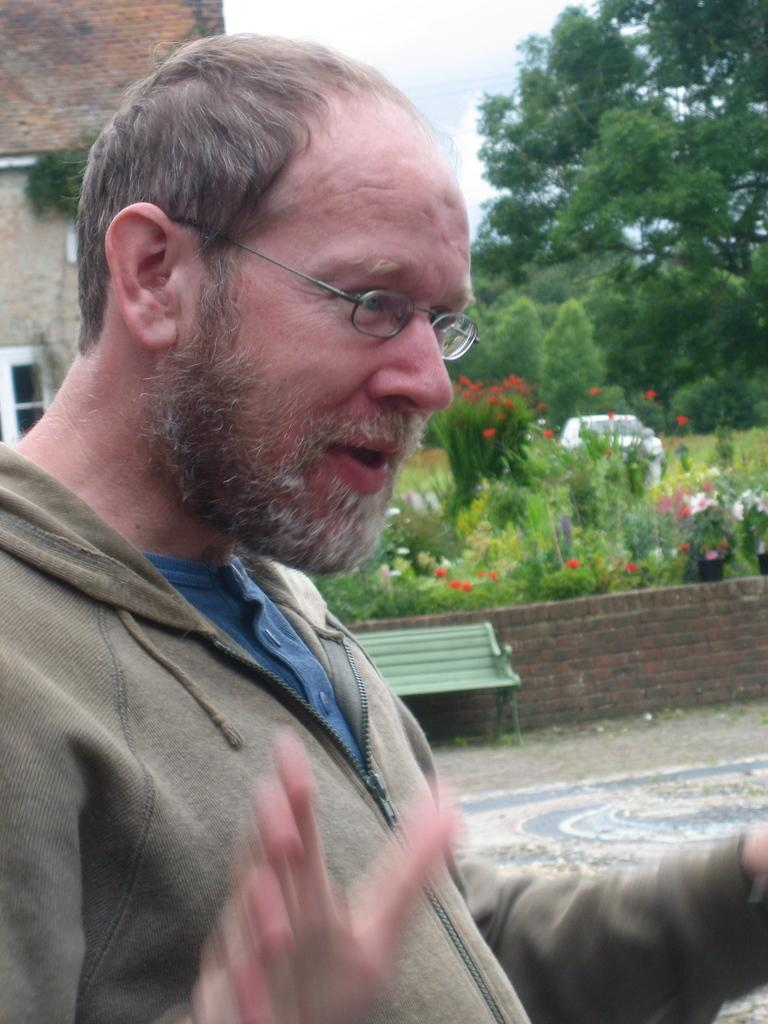What is the person in the image wearing? The person in the image is wearing a brown jacket. What can be seen in the background of the image? There is a building, a bench, trees, and colorful flowers in the background of the image. Can you describe the building in the background? The building in the background has windows. What is the color of the sky in the image? The sky is white in color. What type of silk is being used to make noise in the image? There is no silk or noise present in the image. 